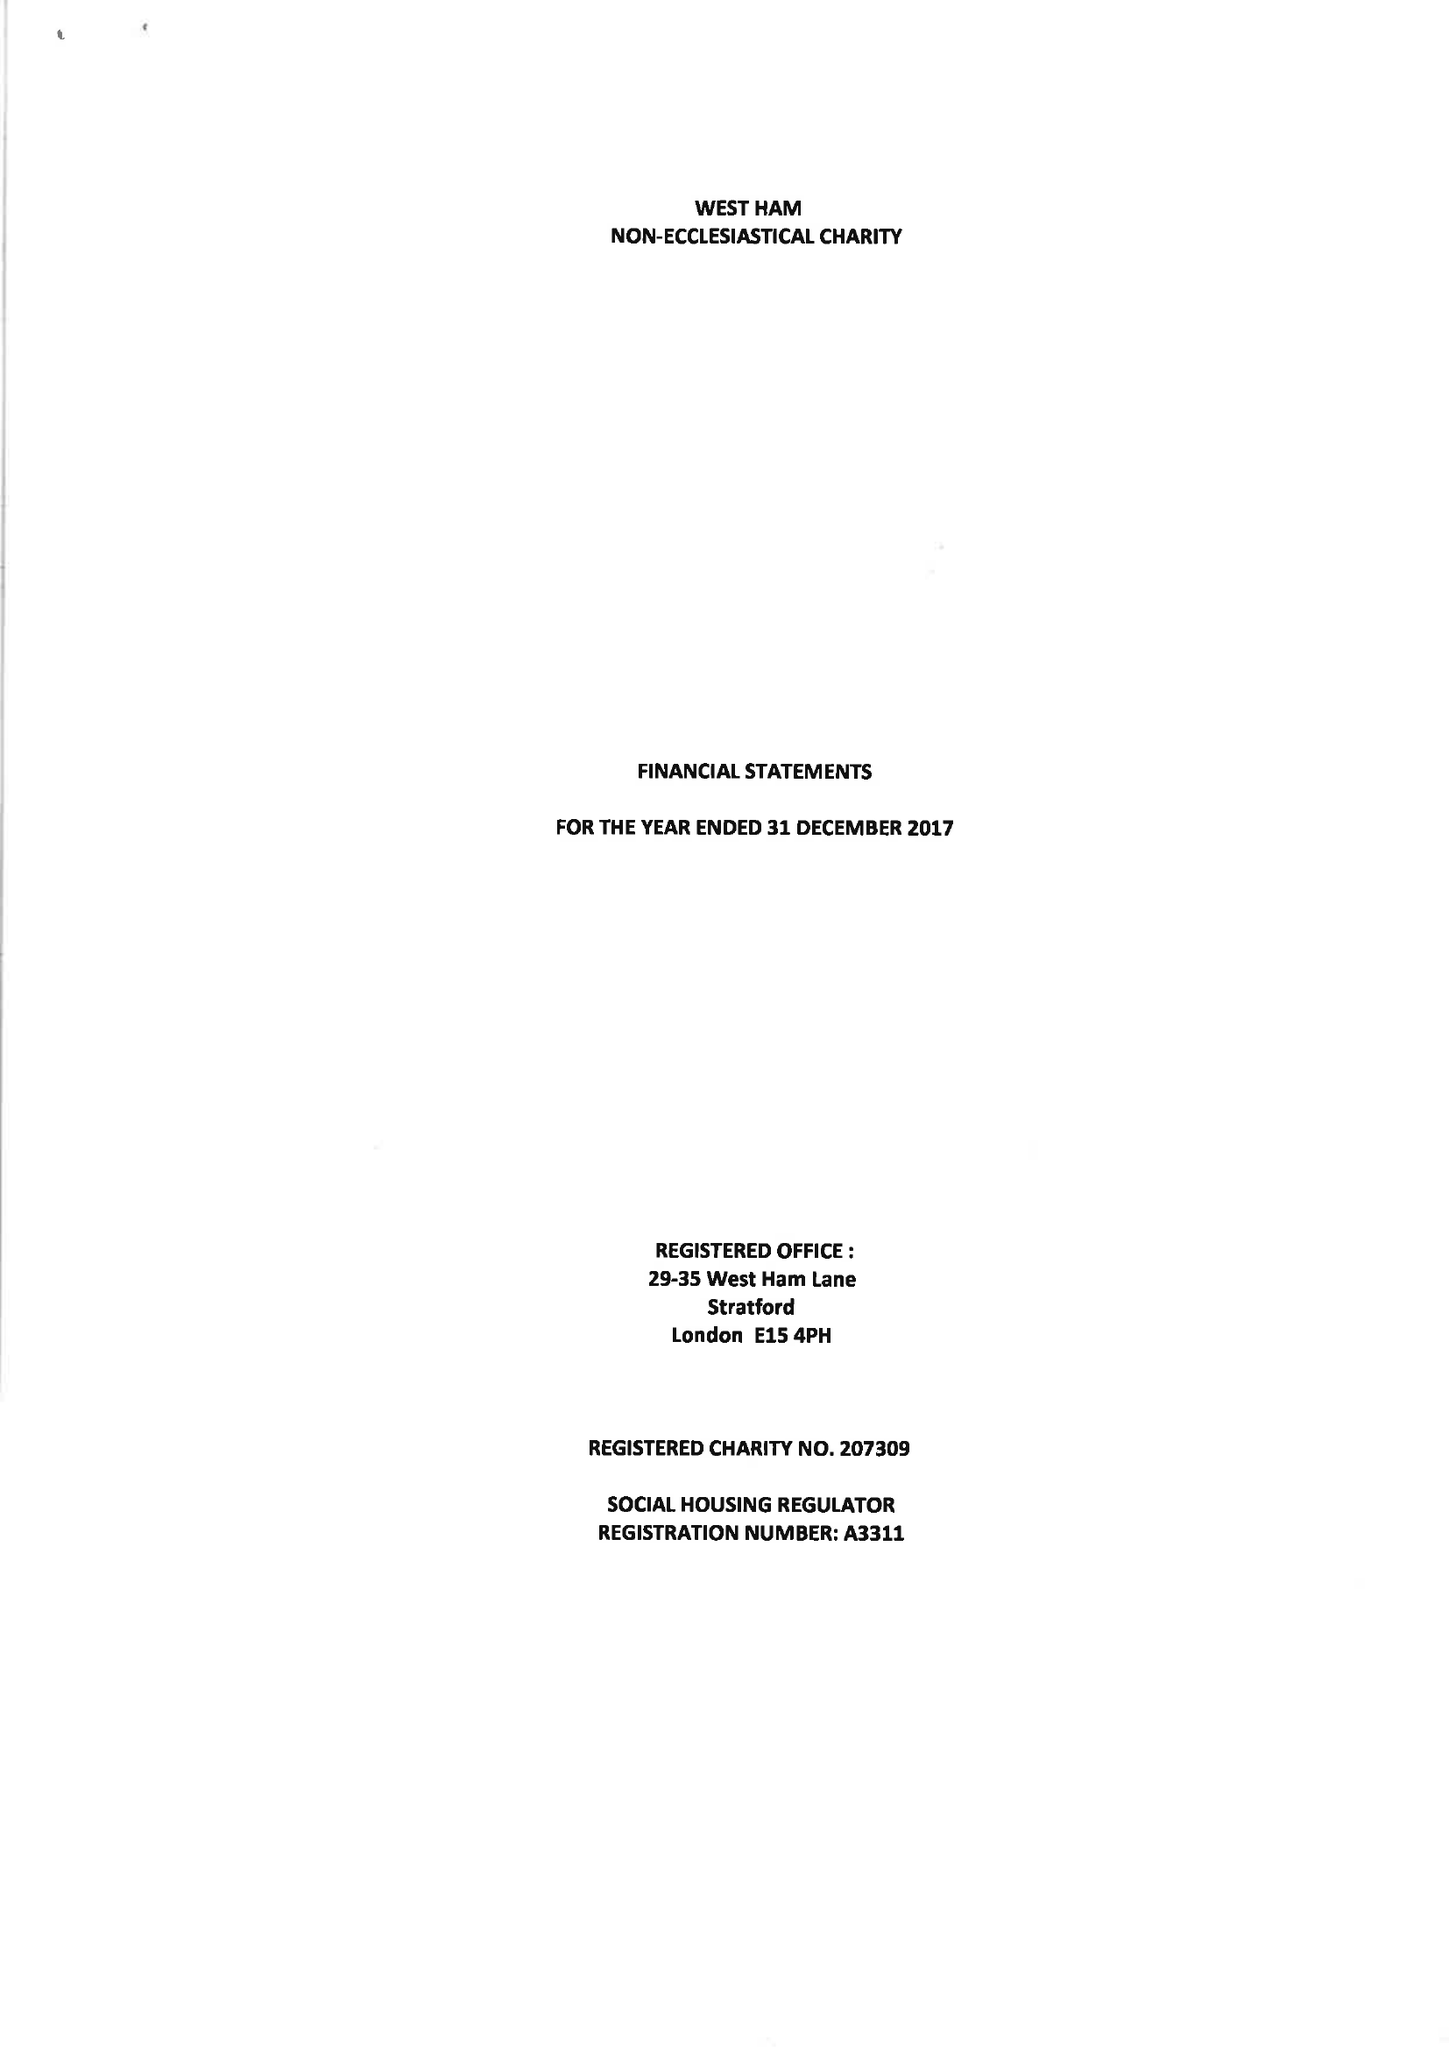What is the value for the charity_number?
Answer the question using a single word or phrase. 207309 